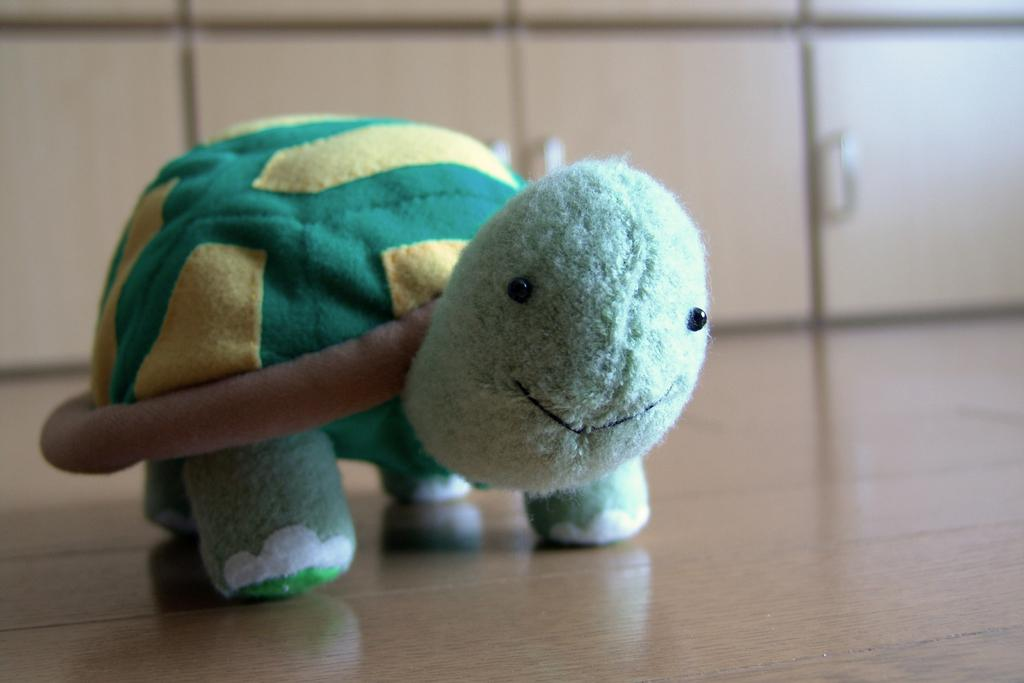What is the main subject of the image? There is a doll in the image. Where is the doll located in the image? The doll is in the middle of the image. What color is the doll? The doll is green in color. What type of cushion is the doll sitting on in the image? There is no cushion present in the image; the doll is not sitting on anything. 